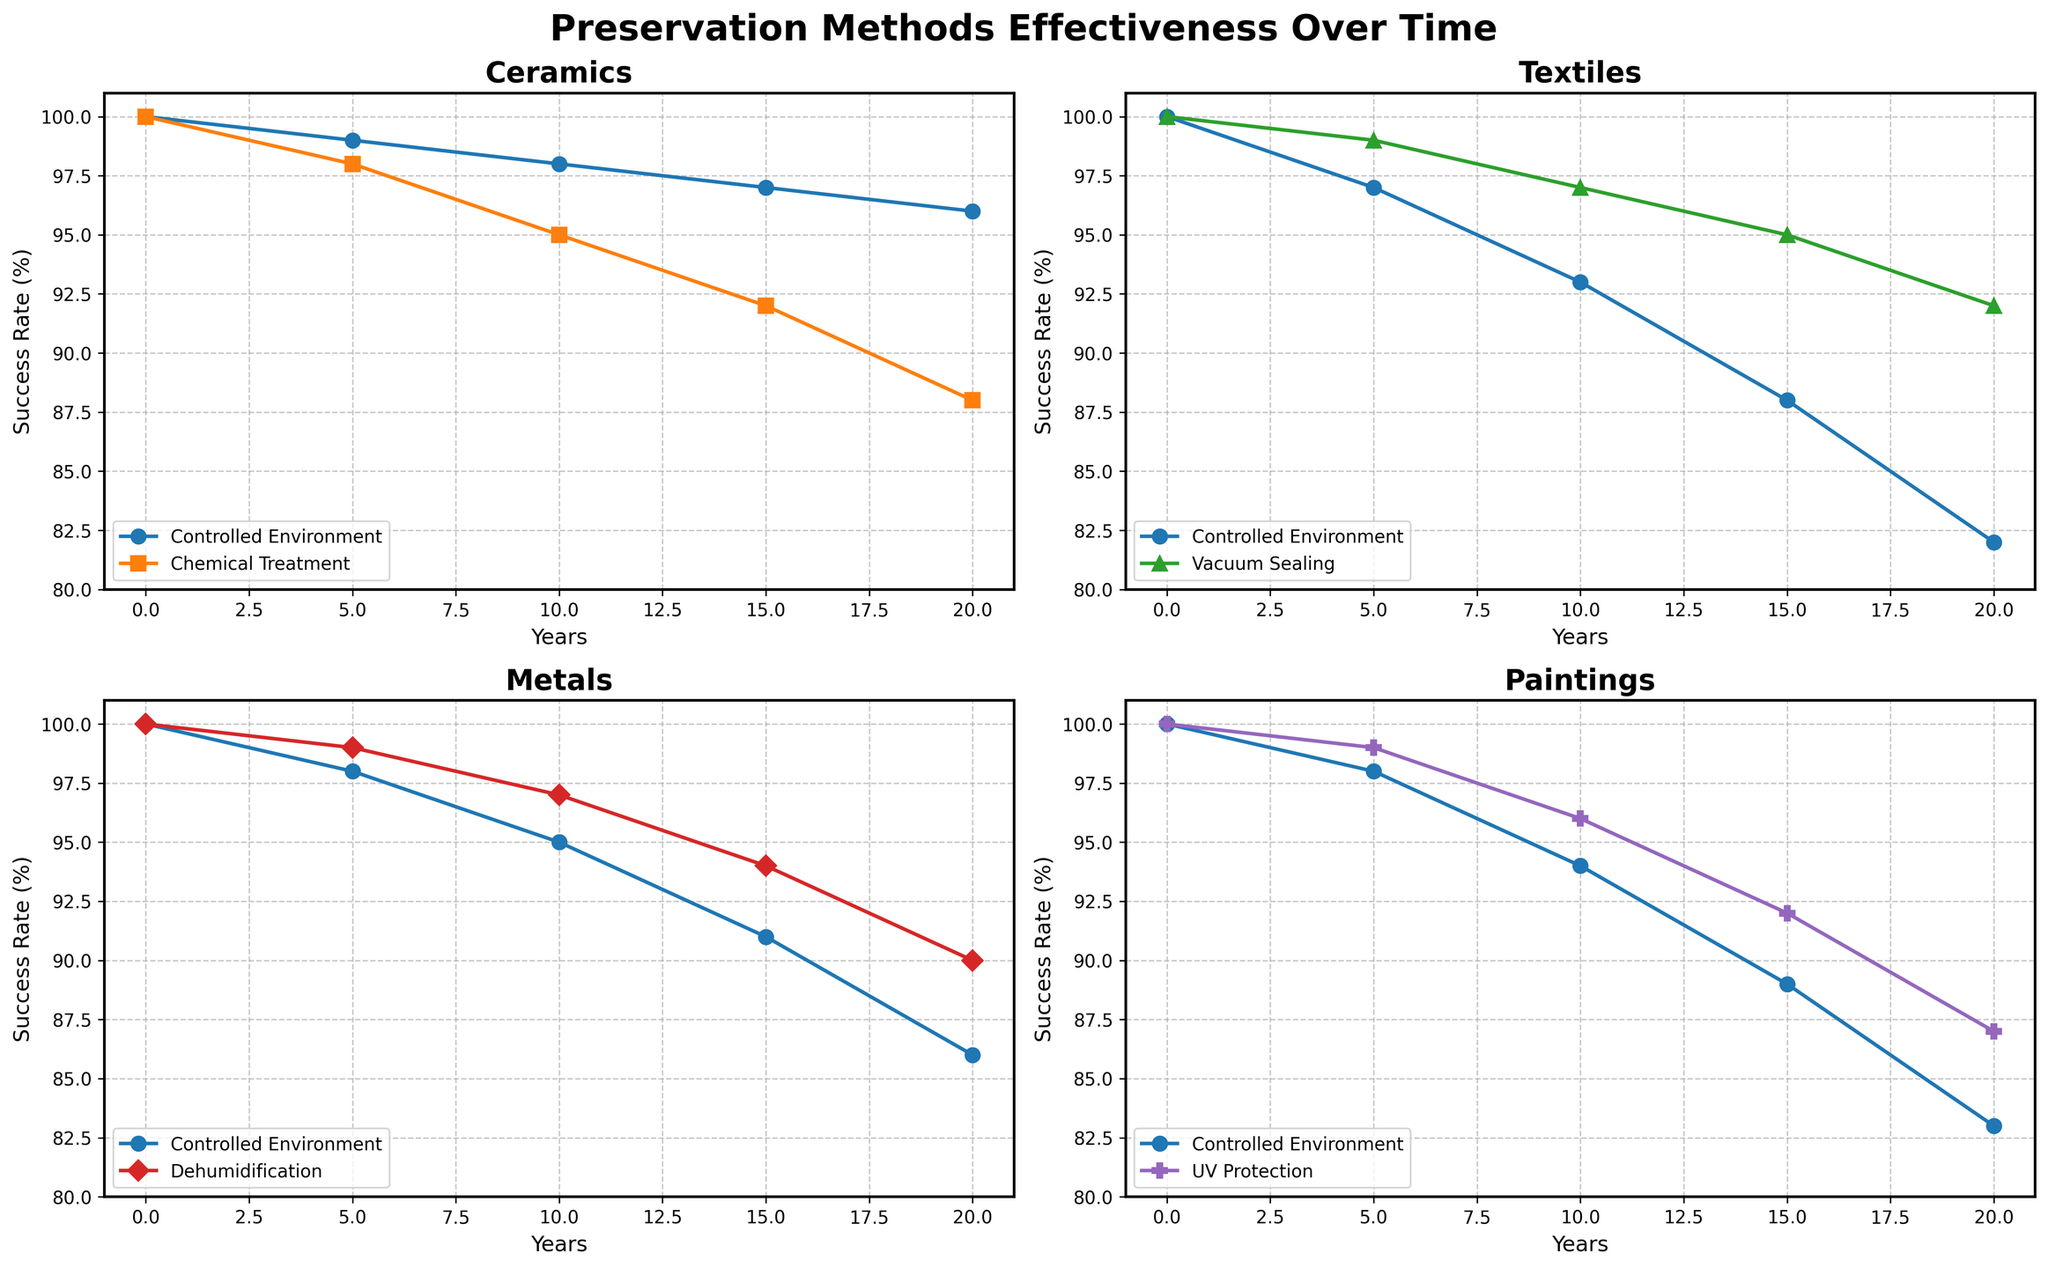Which artifact type shows the least success rate after 20 years for the method Controlled Environment? To find the answer, locate the subplots for each artifact type. In each subplot, find the Controlled Environment method's curve and observe its success rate at the 20-year mark. Among Ceramics (96%), Textiles (82%), Metals (86%), and Paintings (83%), Textiles have the lowest success rate.
Answer: Textiles Which preservation method displayed the smallest drop in success rate for Ceramics over the 20-year period? Look at the subplot for Ceramics and compare the slopes of the Controlled Environment and Chemical Treatment methods. Controlled Environment decreases from 100% to 96%, while Chemical Treatment decreases from 100% to 88%. The Controlled Environment displayed the smaller drop (4%).
Answer: Controlled Environment Between Controlled Environment and UV Protection, which method yields a higher success rate for Paintings at 15 years? In the Paintings subplot, compare the success rates for Controlled Environment and UV Protection at the 15-year point. Controlled Environment shows 89%, and UV Protection shows 92%.
Answer: UV Protection What is the average success rate of Vacuum Sealing for Textiles at the 5, 10, and 15-year marks? In the Textiles subplot, locate the data points for Vacuum Sealing at 5 (99%), 10 (97%), and 15 (95%) years. Calculate the average: (99 + 97 + 95)/3 = 97.
Answer: 97 Which artifact type has the most consistent success rate over 20 years when using Controlled Environment? Compare the slopes of the Controlled Environment curves across all artifact subplots: Ceramics (100% to 96%), Textiles (100% to 82%), Metals (100% to 86%), and Paintings (100% to 83%). The smallest change is for Ceramics (4%), so it is the most consistent.
Answer: Ceramics For Metals, which preservation method shows a higher success rate at the 10-year mark? In the Metals subplot, compare the success rates of Controlled Environment and Dehumidification at the 10-year point. Controlled Environment is at 95%, and Dehumidification is at 97%.
Answer: Dehumidification How does the success rate difference for Chemical Treatment in Ceramics and Dehumidification in Metals compare after 20 years? Find the 20-year success rates for Chemical Treatment in Ceramics (88%) and Dehumidification in Metals (90%). The difference is 90 - 88 = 2%.
Answer: 2% For Textiles, what is the difference in the success rate between Controlled Environment and Vacuum Sealing at 10 years? In the Textiles subplot, compare the success rates for Controlled Environment (93%) and Vacuum Sealing (97%) at 10 years. The difference is 97 - 93 = 4%.
Answer: 4% Which preservation method for Paintings has the least success rate reduction at 20 years compared to its initial rate? Compare the initial and 20-year success rates of Controlled Environment and UV Protection for Paintings. Controlled Environment drops from 100% to 83% (17%), and UV Protection drops from 100% to 87% (13%). The least reduction is for UV Protection.
Answer: UV Protection 